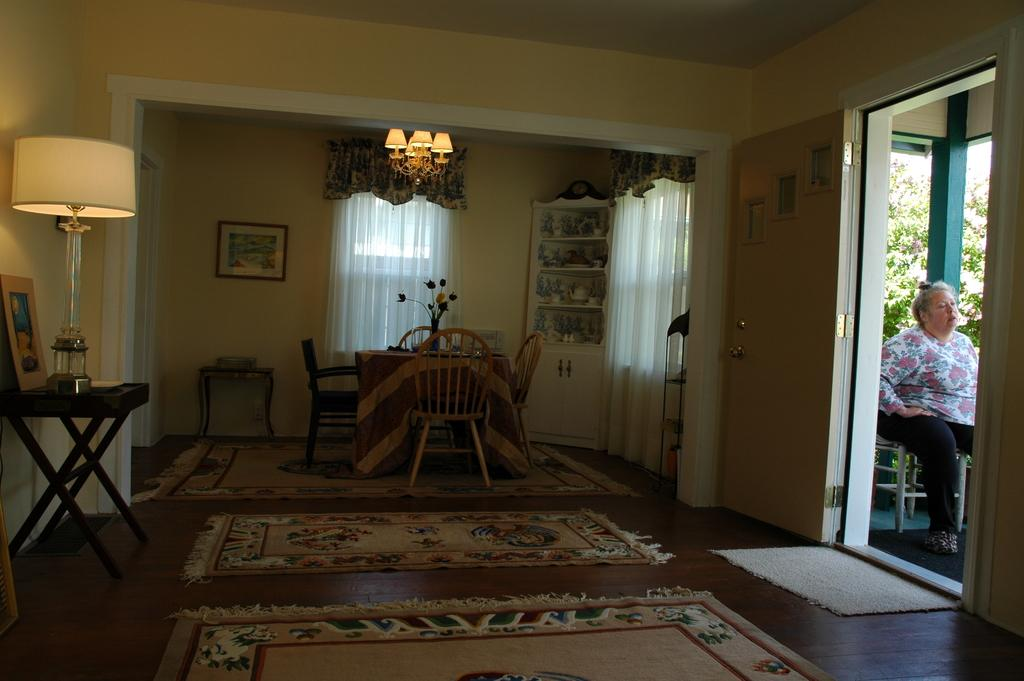What type of furniture is present in the room? There is a dining table in the room. What is another object that provides light in the room? There is a lamp in the room. What is hanging on the wall in the room? There are frames attached to the wall. What is the person in the room doing? There is a person sitting on a chair. What can be seen outside the room through the windows? There are trees visible at the back of the room. What type of railway can be seen passing through the room? There is no railway present in the room; it is a room with a dining table, lamp, frames on the wall, a person sitting on a chair, and trees visible outside. How many bananas are on the dining table? There is no banana present on the dining table in the image. 